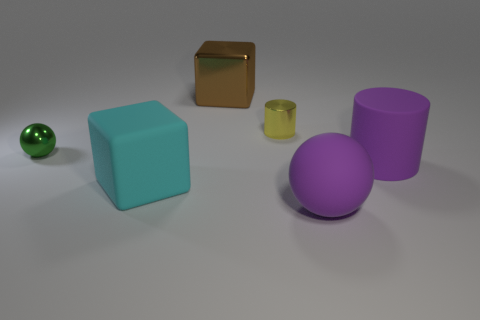Does the large matte sphere have the same color as the big rubber cylinder?
Offer a very short reply. Yes. What shape is the large object that is the same color as the big rubber ball?
Ensure brevity in your answer.  Cylinder. The sphere that is made of the same material as the tiny yellow thing is what size?
Ensure brevity in your answer.  Small. There is a sphere on the right side of the large brown metallic object; does it have the same color as the big rubber cylinder?
Provide a short and direct response. Yes. Is the number of shiny spheres greater than the number of purple things?
Give a very brief answer. No. Are there more large things in front of the tiny cylinder than small shiny cylinders that are to the left of the cyan rubber object?
Your answer should be very brief. Yes. How big is the metal thing that is in front of the brown shiny cube and on the right side of the big cyan block?
Ensure brevity in your answer.  Small. What number of purple things are the same size as the brown metallic object?
Ensure brevity in your answer.  2. There is a thing that is the same color as the matte ball; what is it made of?
Ensure brevity in your answer.  Rubber. Do the large thing that is left of the brown metal block and the brown metal thing have the same shape?
Make the answer very short. Yes. 